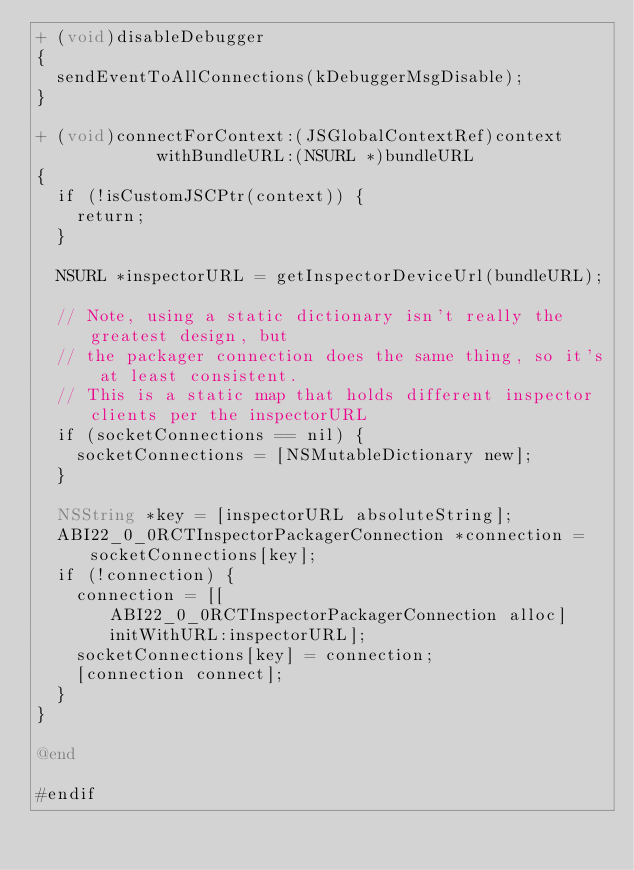<code> <loc_0><loc_0><loc_500><loc_500><_ObjectiveC_>+ (void)disableDebugger
{
  sendEventToAllConnections(kDebuggerMsgDisable);
}

+ (void)connectForContext:(JSGlobalContextRef)context
            withBundleURL:(NSURL *)bundleURL
{
  if (!isCustomJSCPtr(context)) {
    return;
  }

  NSURL *inspectorURL = getInspectorDeviceUrl(bundleURL);

  // Note, using a static dictionary isn't really the greatest design, but
  // the packager connection does the same thing, so it's at least consistent.
  // This is a static map that holds different inspector clients per the inspectorURL
  if (socketConnections == nil) {
    socketConnections = [NSMutableDictionary new];
  }

  NSString *key = [inspectorURL absoluteString];
  ABI22_0_0RCTInspectorPackagerConnection *connection = socketConnections[key];
  if (!connection) {
    connection = [[ABI22_0_0RCTInspectorPackagerConnection alloc] initWithURL:inspectorURL];
    socketConnections[key] = connection;
    [connection connect];
  }
}

@end

#endif
</code> 